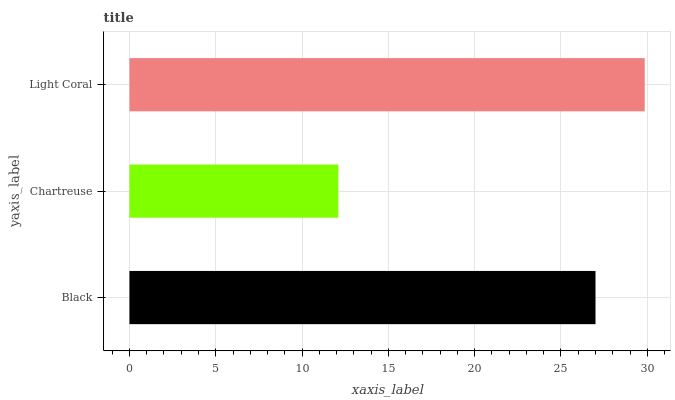Is Chartreuse the minimum?
Answer yes or no. Yes. Is Light Coral the maximum?
Answer yes or no. Yes. Is Light Coral the minimum?
Answer yes or no. No. Is Chartreuse the maximum?
Answer yes or no. No. Is Light Coral greater than Chartreuse?
Answer yes or no. Yes. Is Chartreuse less than Light Coral?
Answer yes or no. Yes. Is Chartreuse greater than Light Coral?
Answer yes or no. No. Is Light Coral less than Chartreuse?
Answer yes or no. No. Is Black the high median?
Answer yes or no. Yes. Is Black the low median?
Answer yes or no. Yes. Is Light Coral the high median?
Answer yes or no. No. Is Chartreuse the low median?
Answer yes or no. No. 